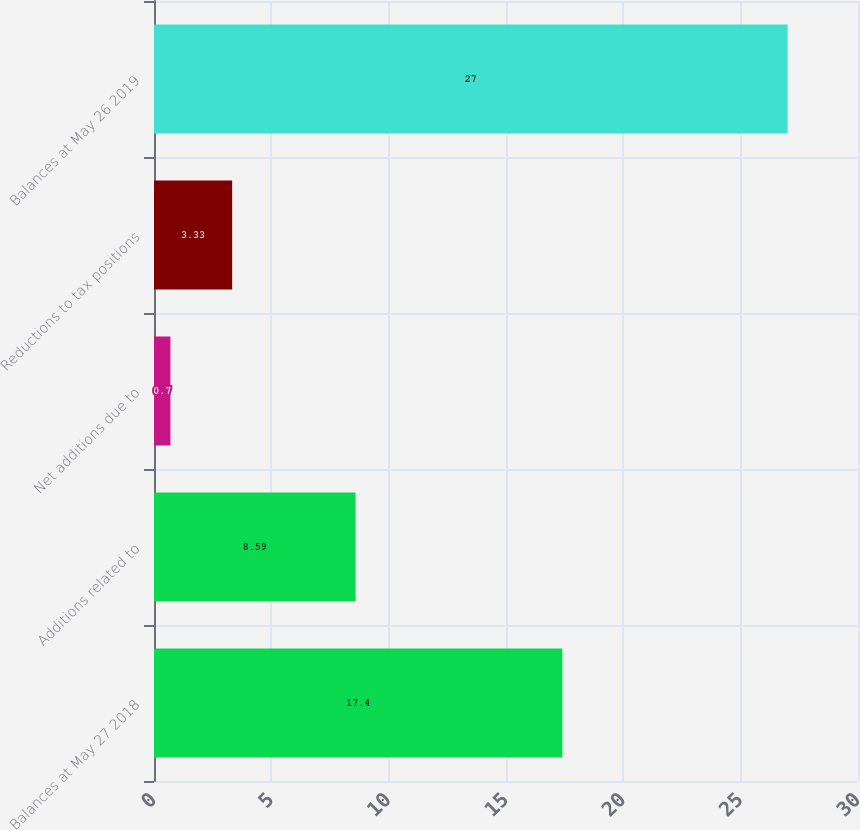Convert chart to OTSL. <chart><loc_0><loc_0><loc_500><loc_500><bar_chart><fcel>Balances at May 27 2018<fcel>Additions related to<fcel>Net additions due to<fcel>Reductions to tax positions<fcel>Balances at May 26 2019<nl><fcel>17.4<fcel>8.59<fcel>0.7<fcel>3.33<fcel>27<nl></chart> 